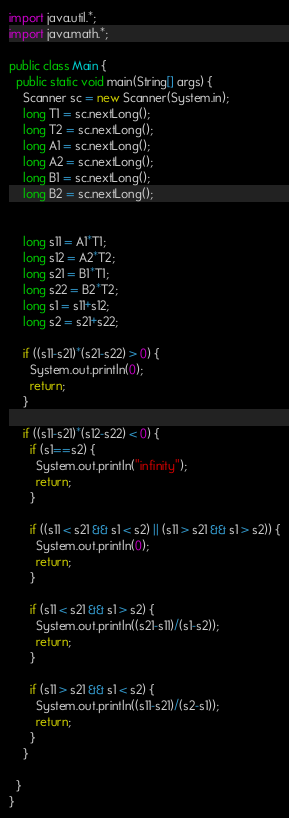Convert code to text. <code><loc_0><loc_0><loc_500><loc_500><_Java_>import java.util.*;
import java.math.*;

public class Main {
  public static void main(String[] args) {
    Scanner sc = new Scanner(System.in);
    long T1 = sc.nextLong();
    long T2 = sc.nextLong();
    long A1 = sc.nextLong();
    long A2 = sc.nextLong();
    long B1 = sc.nextLong();
    long B2 = sc.nextLong();


    long s11 = A1*T1;
    long s12 = A2*T2;
    long s21 = B1*T1;
    long s22 = B2*T2;
    long s1 = s11+s12;
    long s2 = s21+s22;

    if ((s11-s21)*(s21-s22) > 0) {
      System.out.println(0);
      return;
    }

    if ((s11-s21)*(s12-s22) < 0) {
      if (s1==s2) {
        System.out.println("infinity");
        return;
      }

      if ((s11 < s21 && s1 < s2) || (s11 > s21 && s1 > s2)) {
        System.out.println(0);
        return;
      }

      if (s11 < s21 && s1 > s2) {
        System.out.println((s21-s11)/(s1-s2));
        return;
      }

      if (s11 > s21 && s1 < s2) {
        System.out.println((s11-s21)/(s2-s1));
        return;
      }
    }

  }
}
</code> 